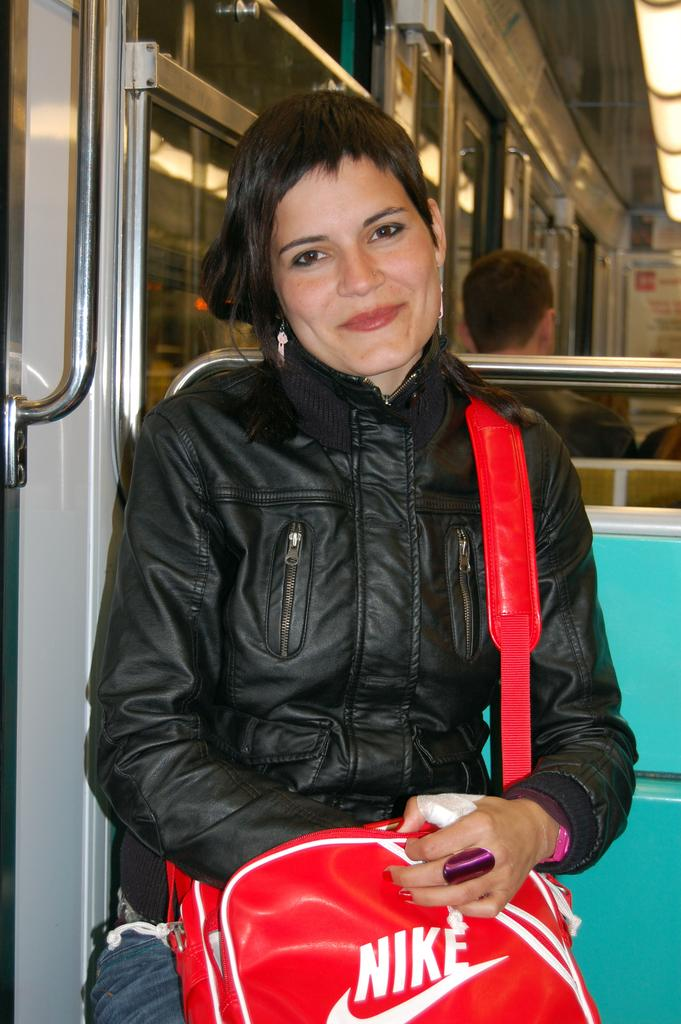<image>
Relay a brief, clear account of the picture shown. The woman on the bus had a red Nike bag. 